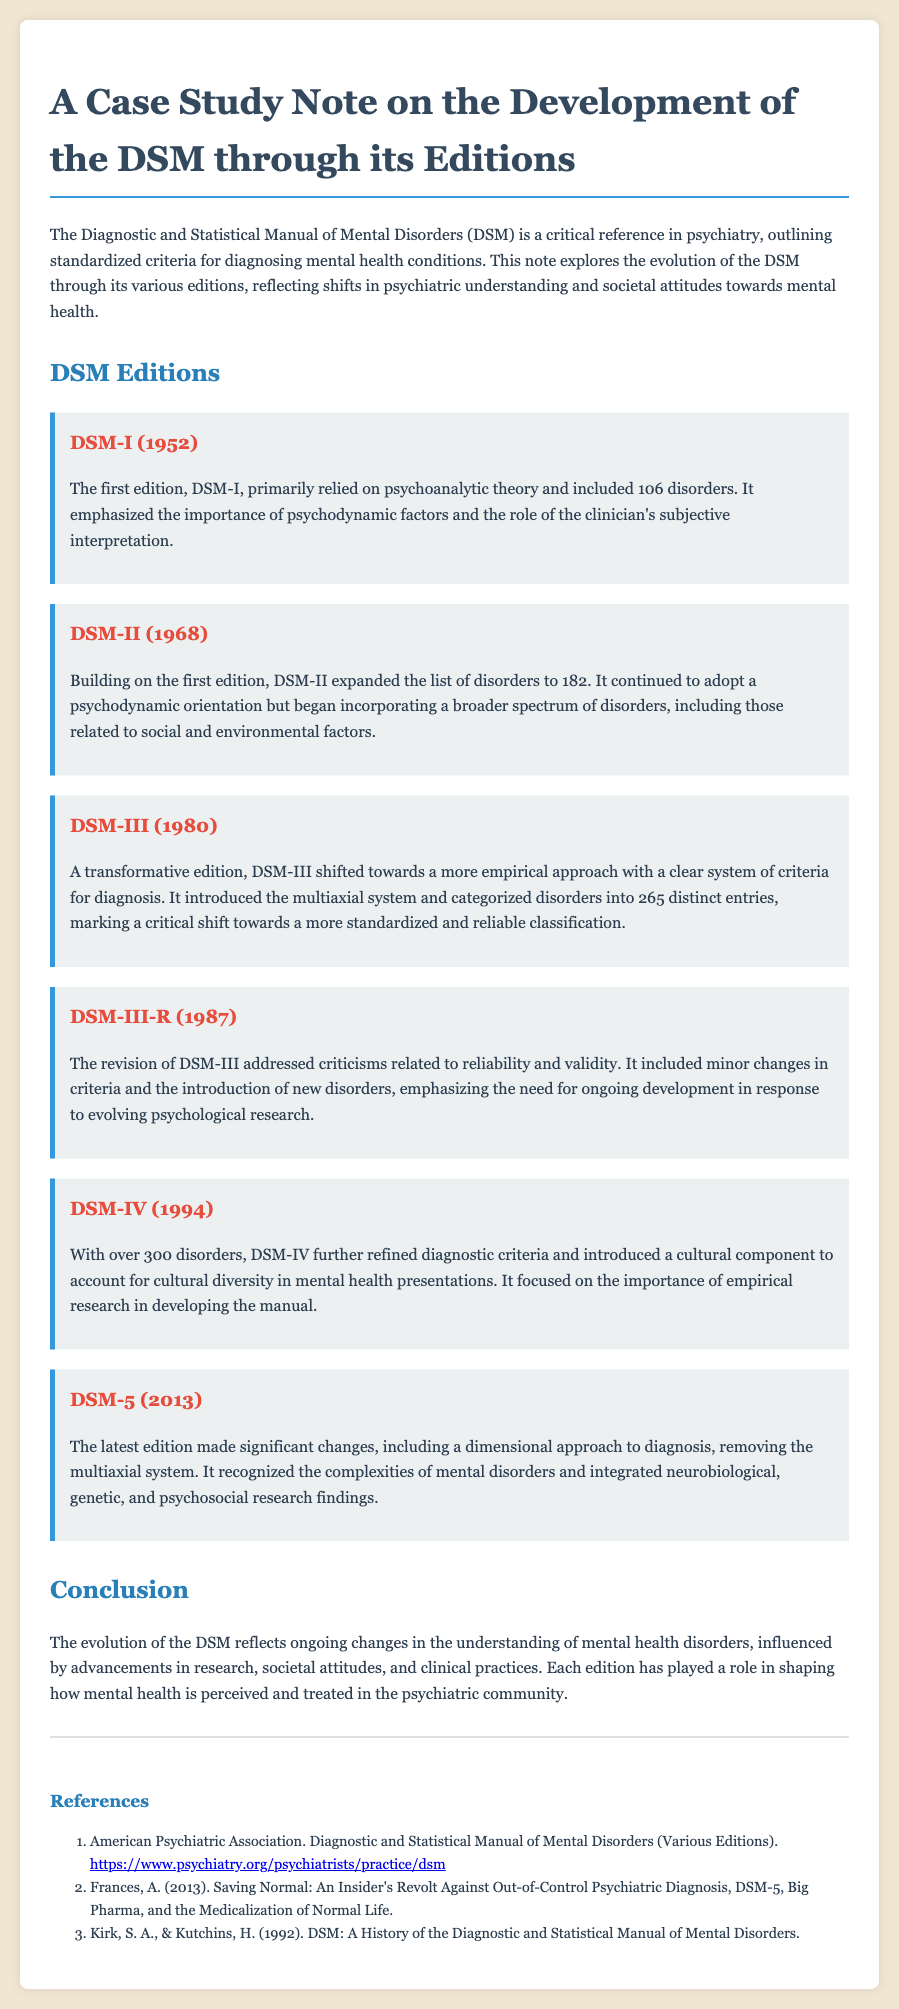What year was DSM-I published? The first edition, DSM-I, was published in 1952.
Answer: 1952 How many disorders were included in DSM-III? DSM-III introduced 265 distinct entries, categorizing various disorders.
Answer: 265 What significant approach was introduced in DSM-5? DSM-5 made significant changes, including a dimensional approach to diagnosis.
Answer: Dimensional Which DSM edition emphasized cultural diversity? DSM-IV focused on the importance of cultural diversity in mental health presentations.
Answer: DSM-IV How many disorders were there in DSM-IV? DSM-IV included over 300 disorders, expanding the diagnostic criteria significantly.
Answer: Over 300 What was the primary focus of DSM-I? DSM-I primarily relied on psychoanalytic theory and emphasized psychodynamic factors.
Answer: Psychoanalytic theory What did DSM-III-R aim to address? The revision of DSM-III, known as DSM-III-R, addressed criticisms related to reliability and validity.
Answer: Reliability and validity What was a critical shift in DSM-III compared to its predecessors? DSM-III marked a critical shift towards a more standardized and reliable classification system.
Answer: Standardized classification 